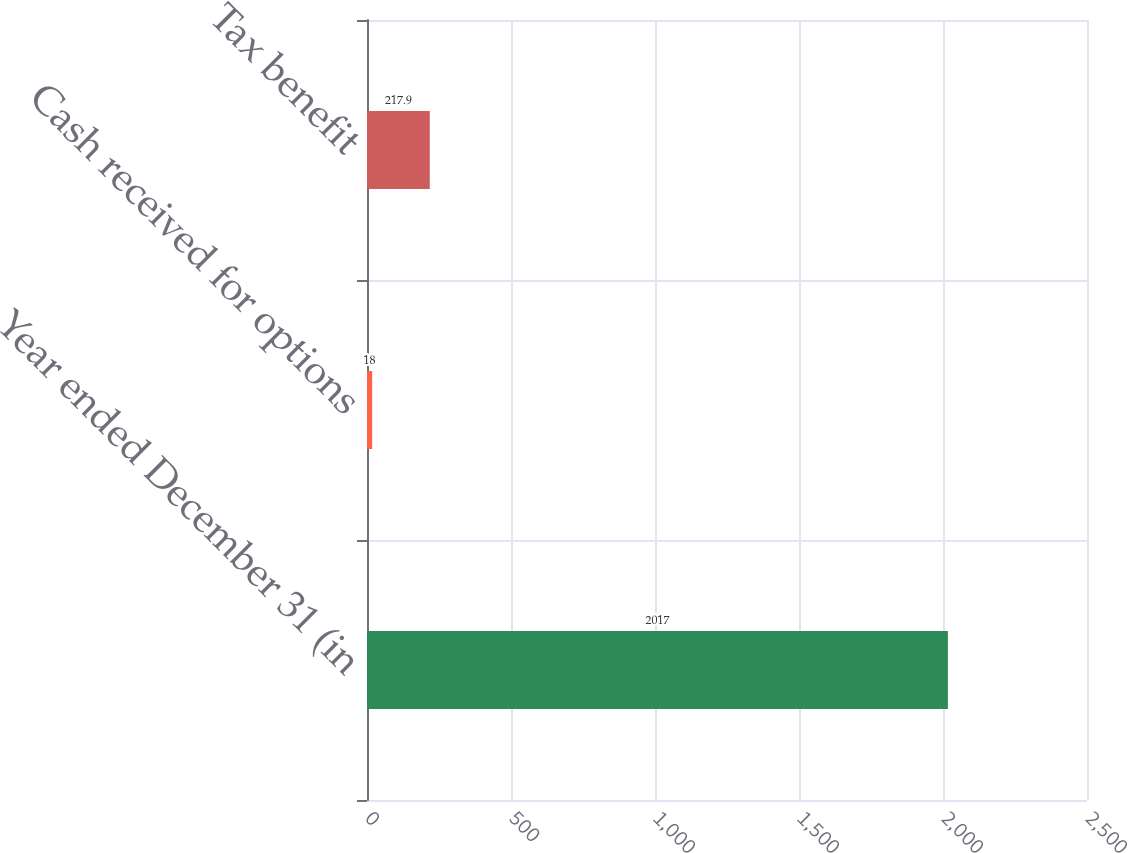Convert chart to OTSL. <chart><loc_0><loc_0><loc_500><loc_500><bar_chart><fcel>Year ended December 31 (in<fcel>Cash received for options<fcel>Tax benefit<nl><fcel>2017<fcel>18<fcel>217.9<nl></chart> 